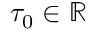Convert formula to latex. <formula><loc_0><loc_0><loc_500><loc_500>\tau _ { 0 } \in \mathbb { R }</formula> 